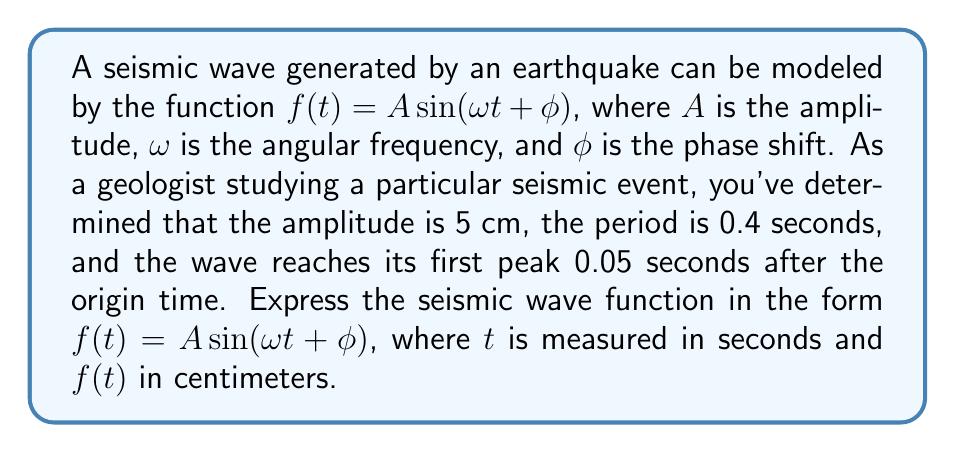Can you answer this question? Let's approach this step-by-step:

1) We're given that $A = 5$ cm.

2) To find $\omega$, we use the relationship between angular frequency and period:
   $$\omega = \frac{2\pi}{T}$$
   where $T$ is the period. We know $T = 0.4$ seconds, so:
   $$\omega = \frac{2\pi}{0.4} = 5\pi \text{ rad/s}$$

3) To find $\phi$, we need to use the information about the first peak. In a sine function, the first peak occurs when the argument of sine equals $\frac{\pi}{2}$. So:
   $$\omega t + \phi = \frac{\pi}{2}$$
   We know this happens when $t = 0.05$ seconds, so:
   $$5\pi(0.05) + \phi = \frac{\pi}{2}$$
   $$\frac{\pi}{4} + \phi = \frac{\pi}{2}$$
   $$\phi = \frac{\pi}{2} - \frac{\pi}{4} = \frac{\pi}{4}$$

4) Now we have all the components to write our function:
   $$f(t) = 5 \sin(5\pi t + \frac{\pi}{4})$$

This function represents the seismic wave, where $t$ is in seconds and $f(t)$ is in centimeters.
Answer: $f(t) = 5 \sin(5\pi t + \frac{\pi}{4})$ 